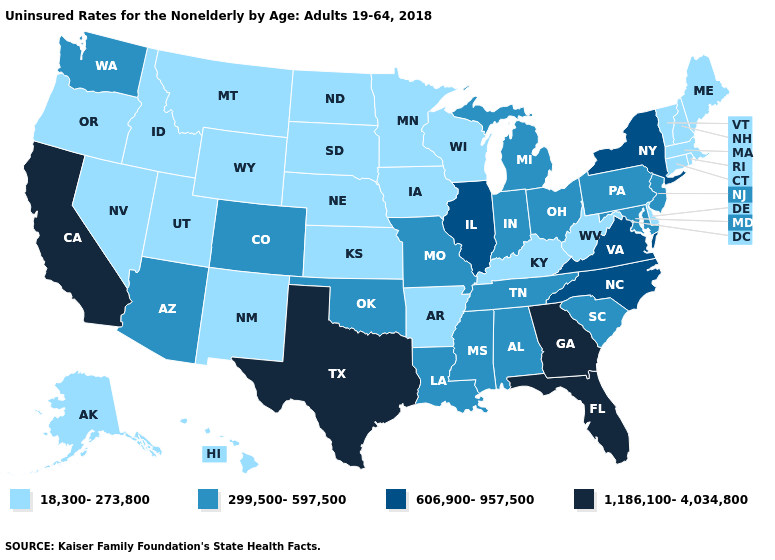Which states hav the highest value in the West?
Write a very short answer. California. Name the states that have a value in the range 18,300-273,800?
Be succinct. Alaska, Arkansas, Connecticut, Delaware, Hawaii, Idaho, Iowa, Kansas, Kentucky, Maine, Massachusetts, Minnesota, Montana, Nebraska, Nevada, New Hampshire, New Mexico, North Dakota, Oregon, Rhode Island, South Dakota, Utah, Vermont, West Virginia, Wisconsin, Wyoming. Which states hav the highest value in the West?
Quick response, please. California. Among the states that border Iowa , which have the highest value?
Short answer required. Illinois. What is the highest value in the South ?
Keep it brief. 1,186,100-4,034,800. Does the map have missing data?
Quick response, please. No. What is the value of Vermont?
Short answer required. 18,300-273,800. How many symbols are there in the legend?
Write a very short answer. 4. What is the highest value in the USA?
Concise answer only. 1,186,100-4,034,800. Name the states that have a value in the range 1,186,100-4,034,800?
Give a very brief answer. California, Florida, Georgia, Texas. Name the states that have a value in the range 1,186,100-4,034,800?
Give a very brief answer. California, Florida, Georgia, Texas. Among the states that border Missouri , does Oklahoma have the highest value?
Be succinct. No. Name the states that have a value in the range 18,300-273,800?
Short answer required. Alaska, Arkansas, Connecticut, Delaware, Hawaii, Idaho, Iowa, Kansas, Kentucky, Maine, Massachusetts, Minnesota, Montana, Nebraska, Nevada, New Hampshire, New Mexico, North Dakota, Oregon, Rhode Island, South Dakota, Utah, Vermont, West Virginia, Wisconsin, Wyoming. 